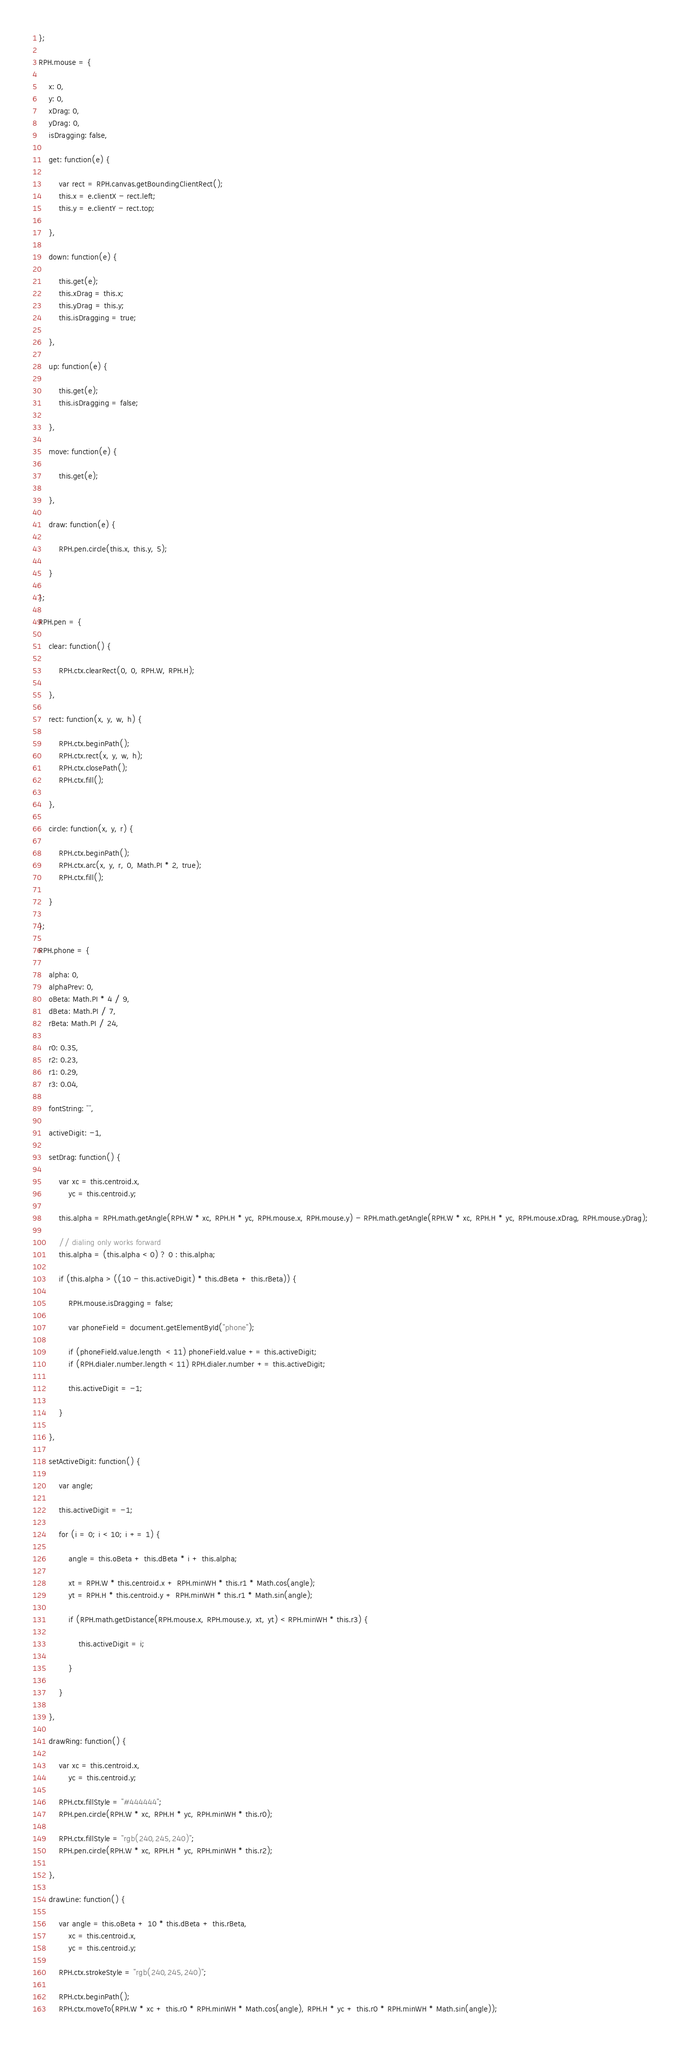<code> <loc_0><loc_0><loc_500><loc_500><_JavaScript_>
};

RPH.mouse = {

    x: 0,
    y: 0,
    xDrag: 0,
    yDrag: 0,
    isDragging: false,

    get: function(e) {

        var rect = RPH.canvas.getBoundingClientRect();
        this.x = e.clientX - rect.left;
        this.y = e.clientY - rect.top;

    },

    down: function(e) {

        this.get(e);
        this.xDrag = this.x;
        this.yDrag = this.y;
        this.isDragging = true;

    },

    up: function(e) {

        this.get(e);
        this.isDragging = false;

    },

    move: function(e) {

        this.get(e);

    },

    draw: function(e) {

        RPH.pen.circle(this.x, this.y, 5);

    }

};

RPH.pen = {

    clear: function() {

        RPH.ctx.clearRect(0, 0, RPH.W, RPH.H);

    },

    rect: function(x, y, w, h) {

        RPH.ctx.beginPath();
        RPH.ctx.rect(x, y, w, h);
        RPH.ctx.closePath();
        RPH.ctx.fill();

    },

    circle: function(x, y, r) {

        RPH.ctx.beginPath();
        RPH.ctx.arc(x, y, r, 0, Math.PI * 2, true);
        RPH.ctx.fill();

    }

};

RPH.phone = {

    alpha: 0,
    alphaPrev: 0,
    oBeta: Math.PI * 4 / 9,
    dBeta: Math.PI / 7,
    rBeta: Math.PI / 24,

    r0: 0.35,
    r2: 0.23,
    r1: 0.29,
    r3: 0.04,

    fontString: "",

    activeDigit: -1,

    setDrag: function() {

        var xc = this.centroid.x,
            yc = this.centroid.y;

        this.alpha = RPH.math.getAngle(RPH.W * xc, RPH.H * yc, RPH.mouse.x, RPH.mouse.y) - RPH.math.getAngle(RPH.W * xc, RPH.H * yc, RPH.mouse.xDrag, RPH.mouse.yDrag);

        // dialing only works forward
        this.alpha = (this.alpha < 0) ? 0 : this.alpha;

        if (this.alpha > ((10 - this.activeDigit) * this.dBeta + this.rBeta)) {

            RPH.mouse.isDragging = false;

            var phoneField = document.getElementById("phone");

            if (phoneField.value.length  < 11) phoneField.value += this.activeDigit;
            if (RPH.dialer.number.length < 11) RPH.dialer.number += this.activeDigit;

            this.activeDigit = -1;

        }

    },

    setActiveDigit: function() {

        var angle;

        this.activeDigit = -1;

        for (i = 0; i < 10; i += 1) {

            angle = this.oBeta + this.dBeta * i + this.alpha;

            xt = RPH.W * this.centroid.x + RPH.minWH * this.r1 * Math.cos(angle);
            yt = RPH.H * this.centroid.y + RPH.minWH * this.r1 * Math.sin(angle);

            if (RPH.math.getDistance(RPH.mouse.x, RPH.mouse.y, xt, yt) < RPH.minWH * this.r3) {

                this.activeDigit = i;

            }

        }

    },

    drawRing: function() {

        var xc = this.centroid.x,
            yc = this.centroid.y;

        RPH.ctx.fillStyle = "#444444";
        RPH.pen.circle(RPH.W * xc, RPH.H * yc, RPH.minWH * this.r0);

        RPH.ctx.fillStyle = "rgb(240,245,240)";
        RPH.pen.circle(RPH.W * xc, RPH.H * yc, RPH.minWH * this.r2);

    },

    drawLine: function() {

        var angle = this.oBeta + 10 * this.dBeta + this.rBeta,
            xc = this.centroid.x,
            yc = this.centroid.y;

        RPH.ctx.strokeStyle = "rgb(240,245,240)";

        RPH.ctx.beginPath();
        RPH.ctx.moveTo(RPH.W * xc + this.r0 * RPH.minWH * Math.cos(angle), RPH.H * yc + this.r0 * RPH.minWH * Math.sin(angle));</code> 